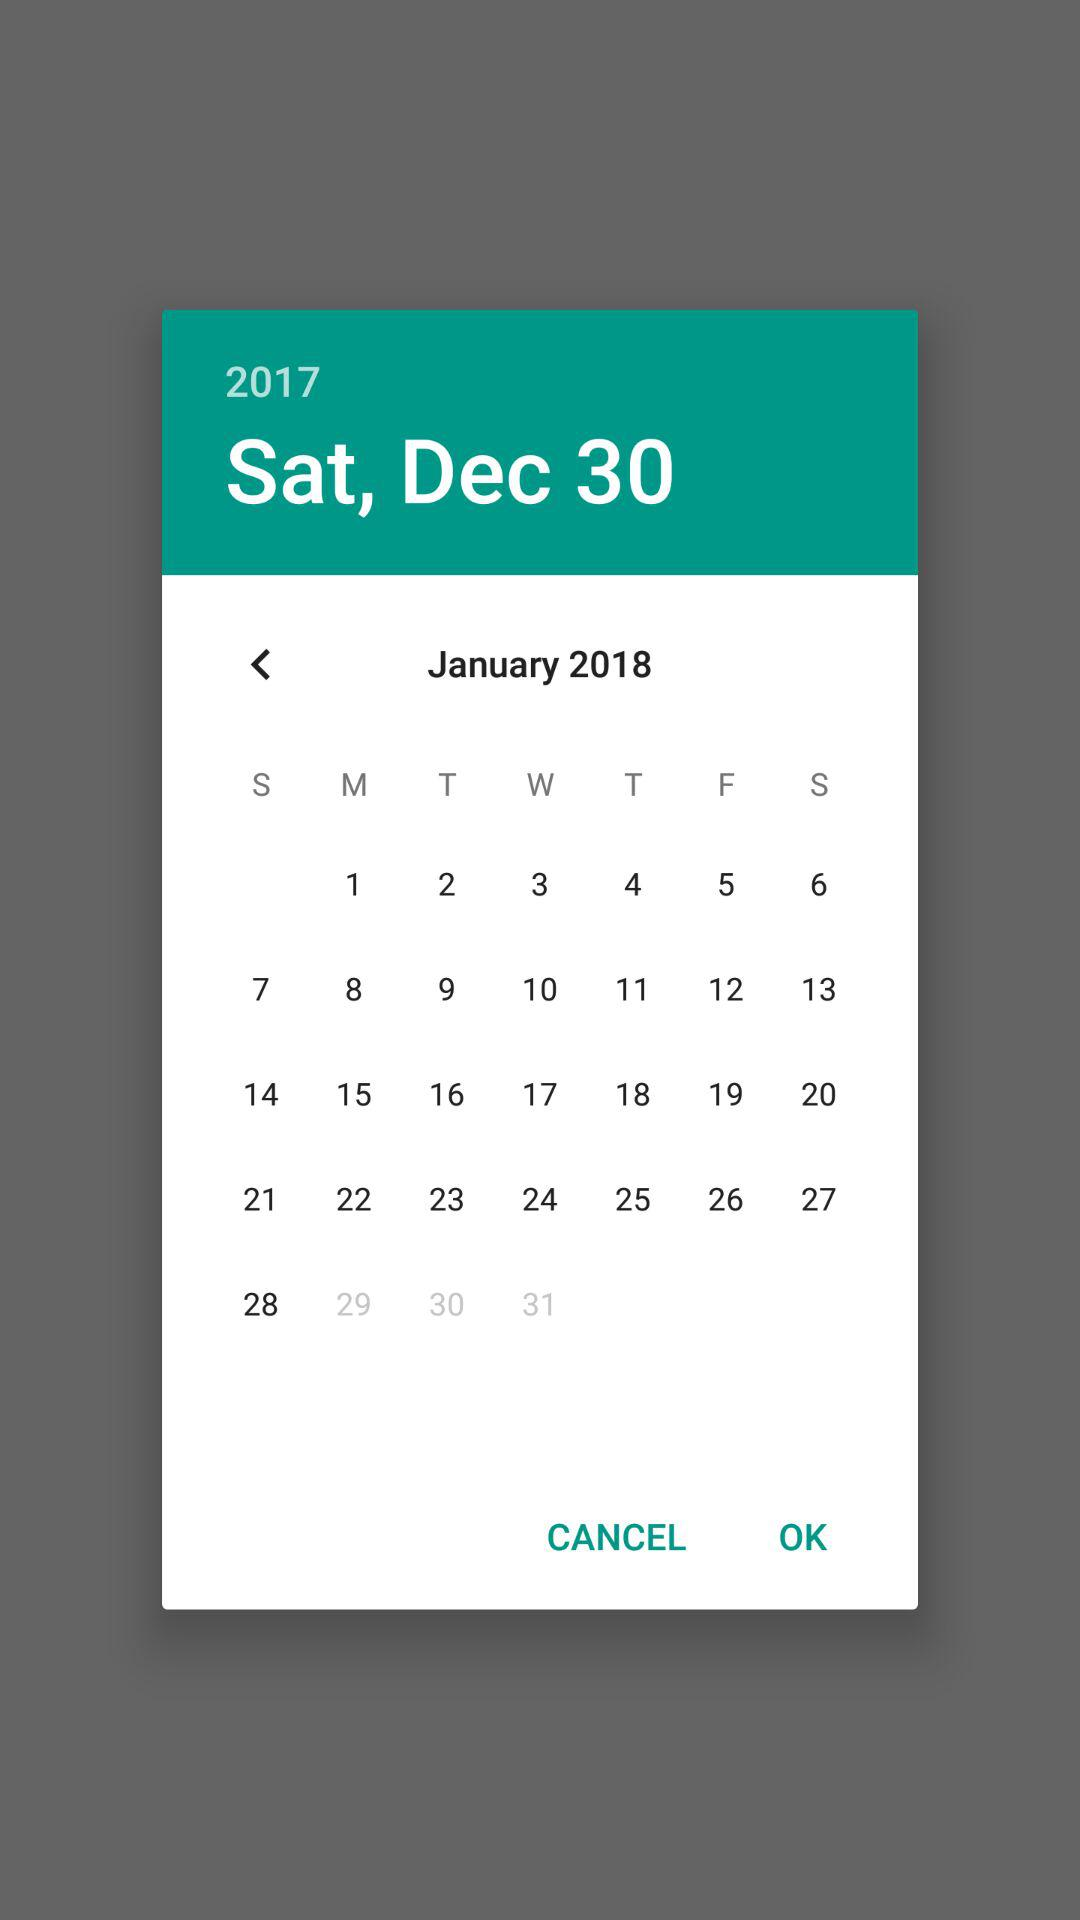Which day is the user's birthday?
When the provided information is insufficient, respond with <no answer>. <no answer> 